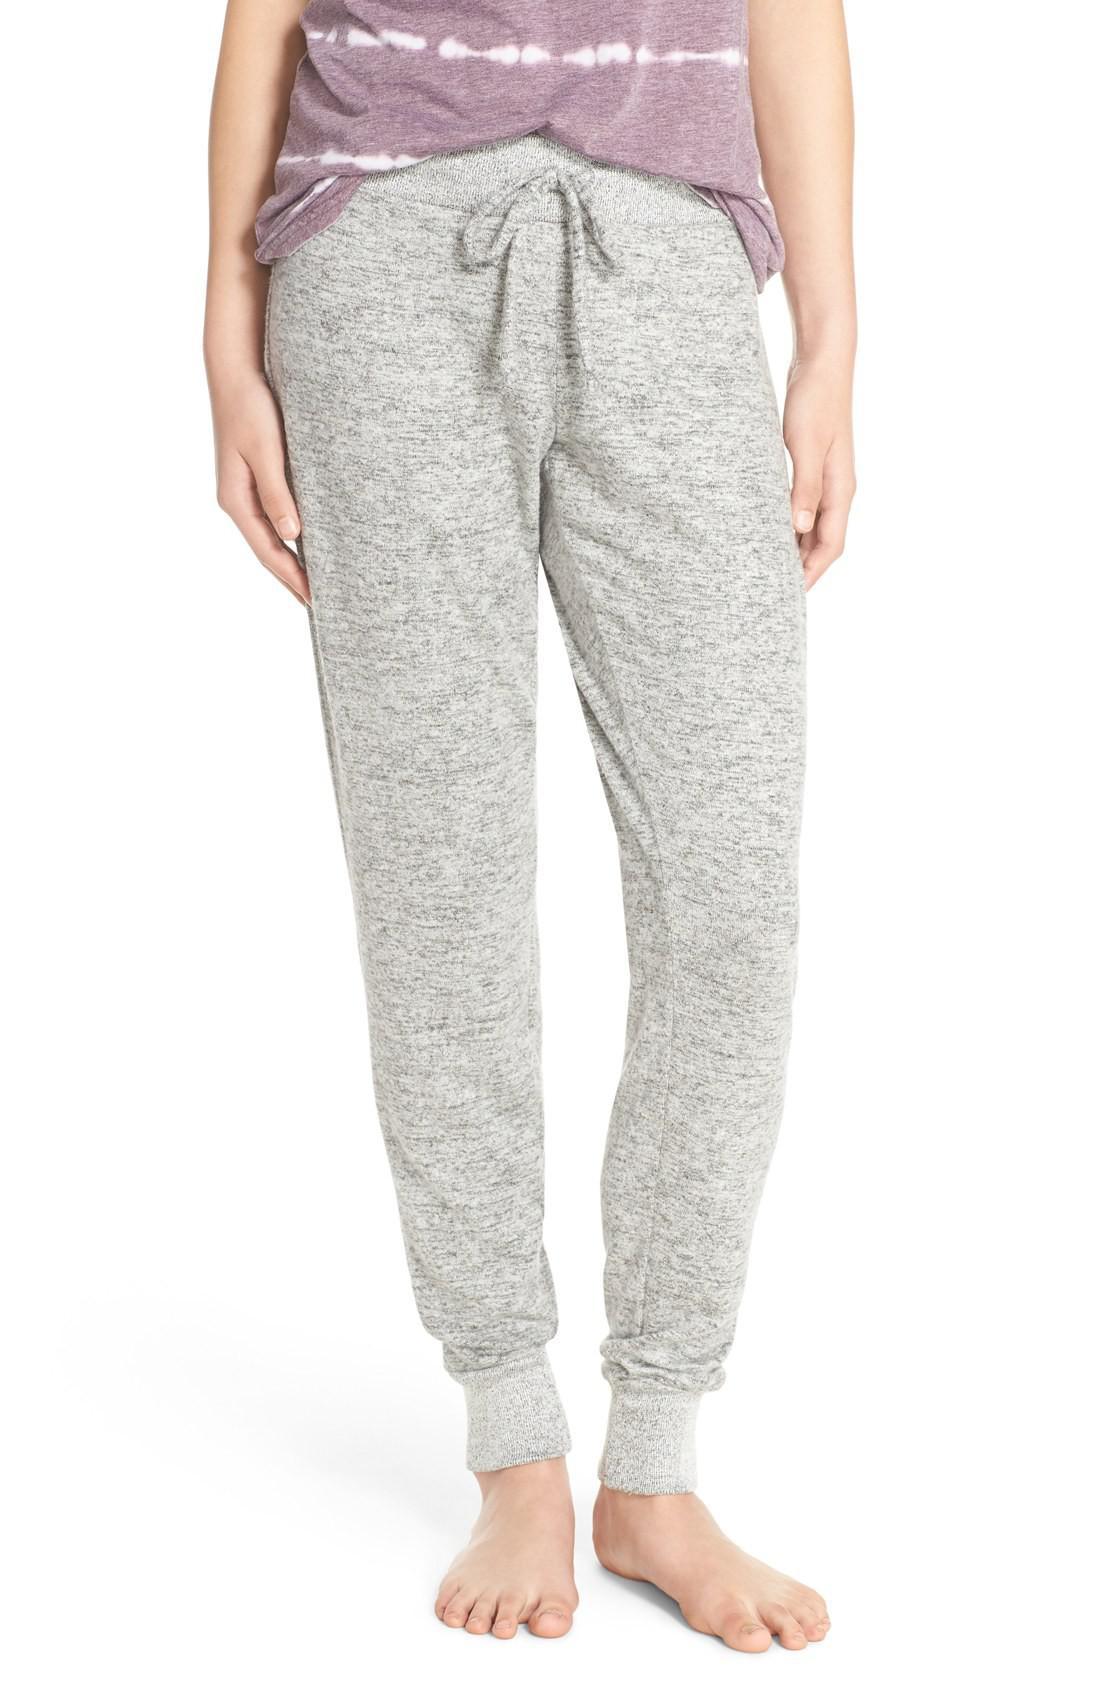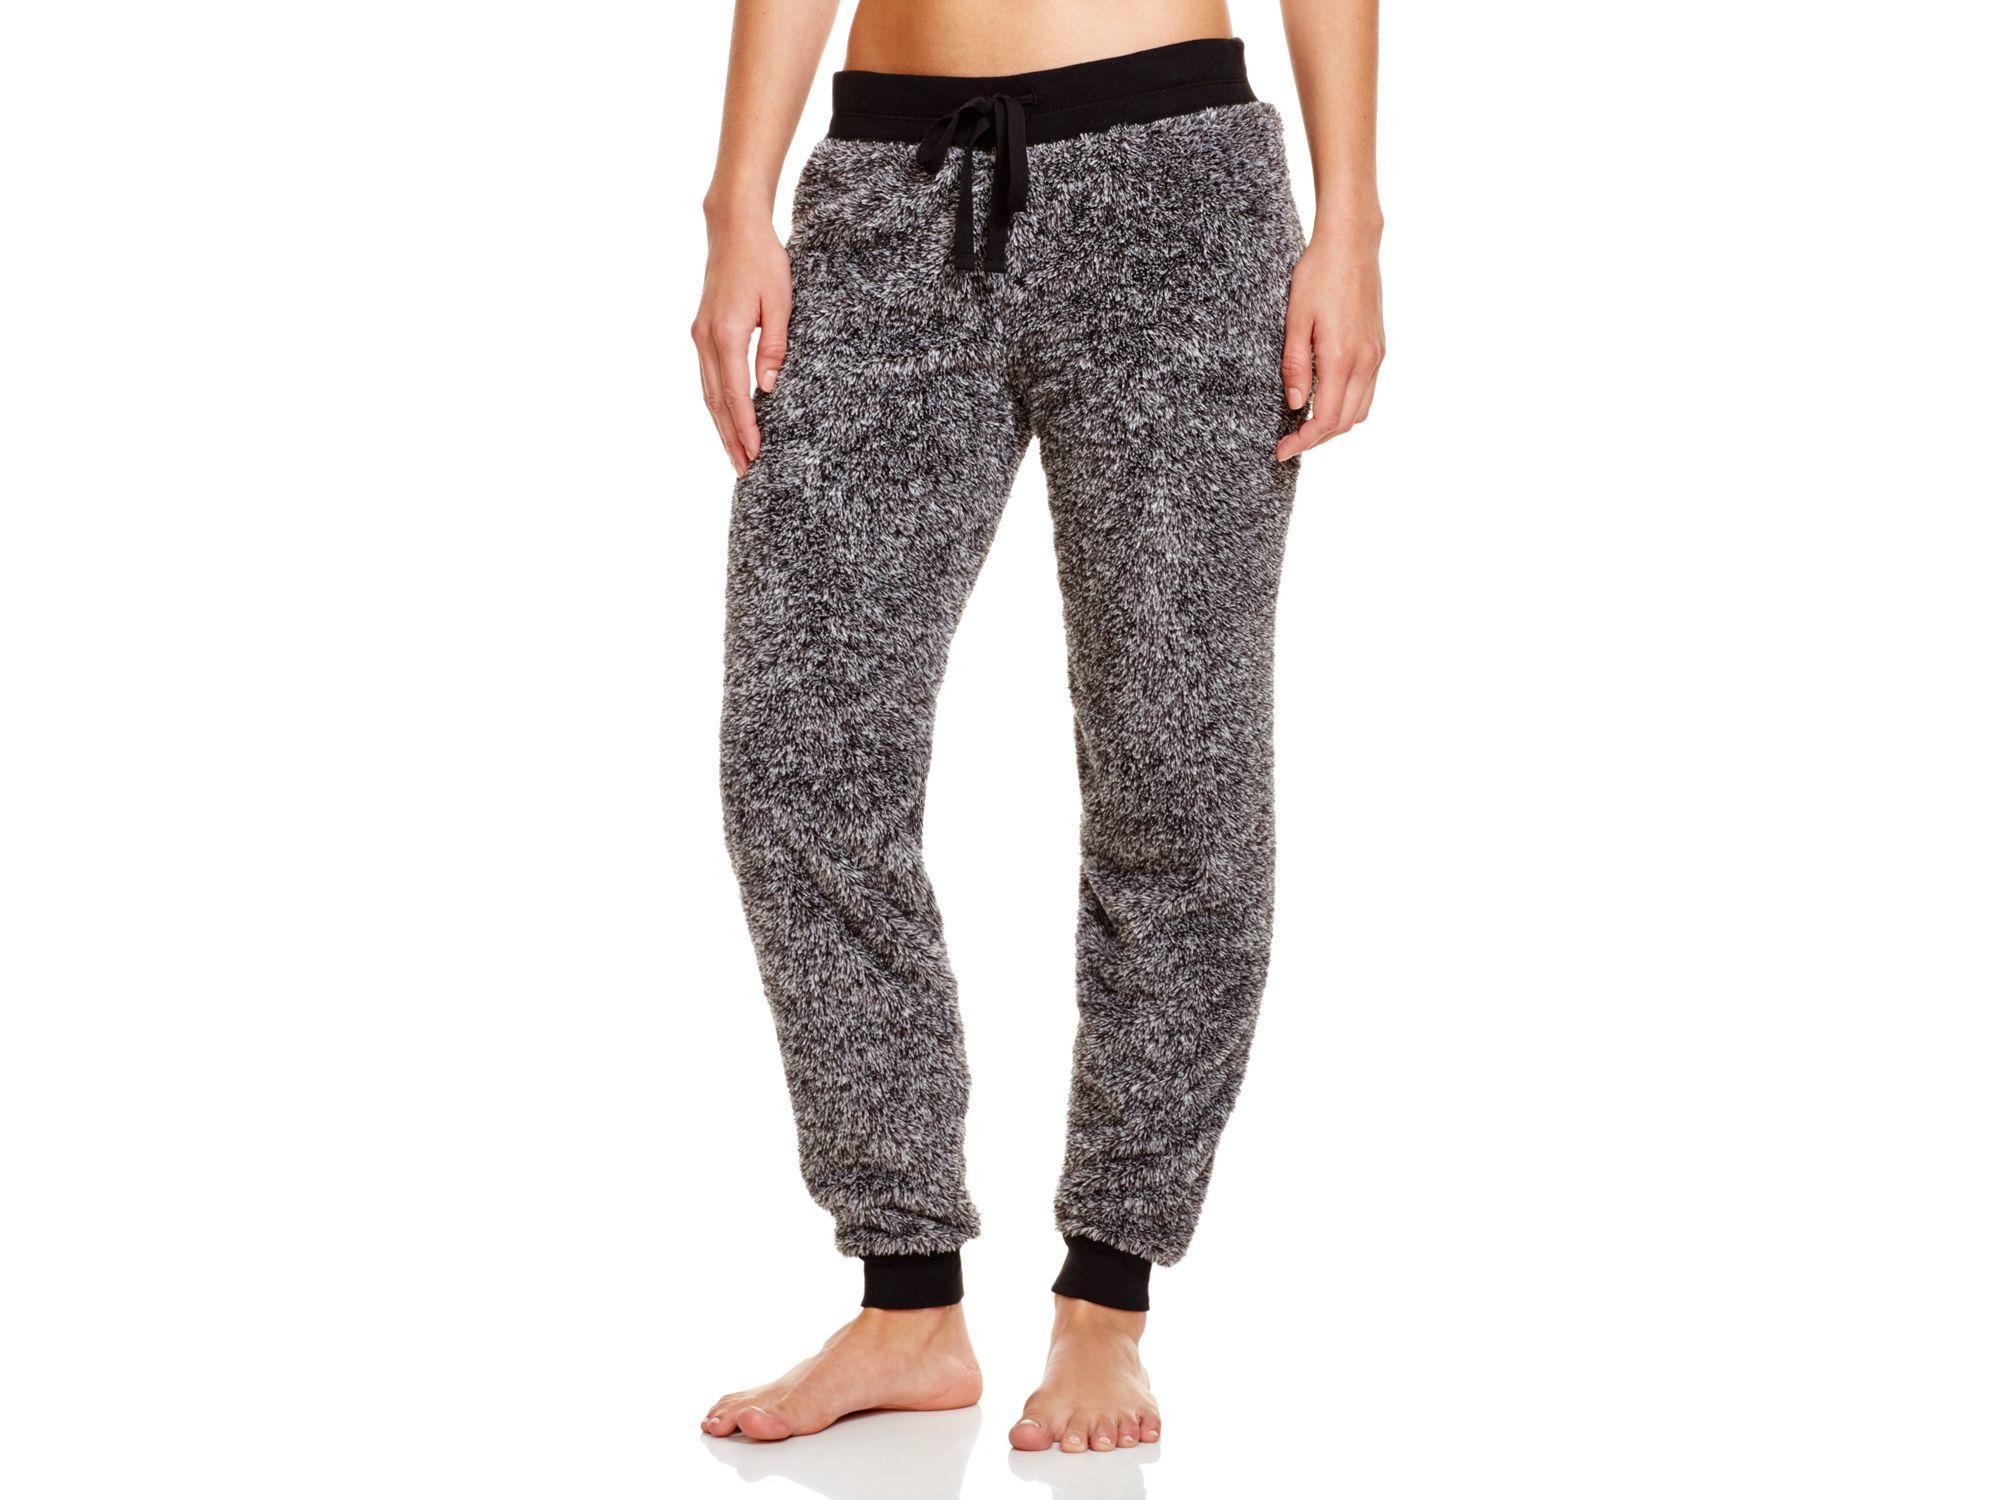The first image is the image on the left, the second image is the image on the right. Given the left and right images, does the statement "The image on the left shows part of a woman's stomach." hold true? Answer yes or no. No. 